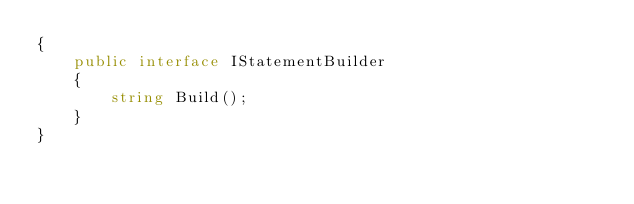<code> <loc_0><loc_0><loc_500><loc_500><_C#_>{
    public interface IStatementBuilder
    {
        string Build();
    }
}</code> 